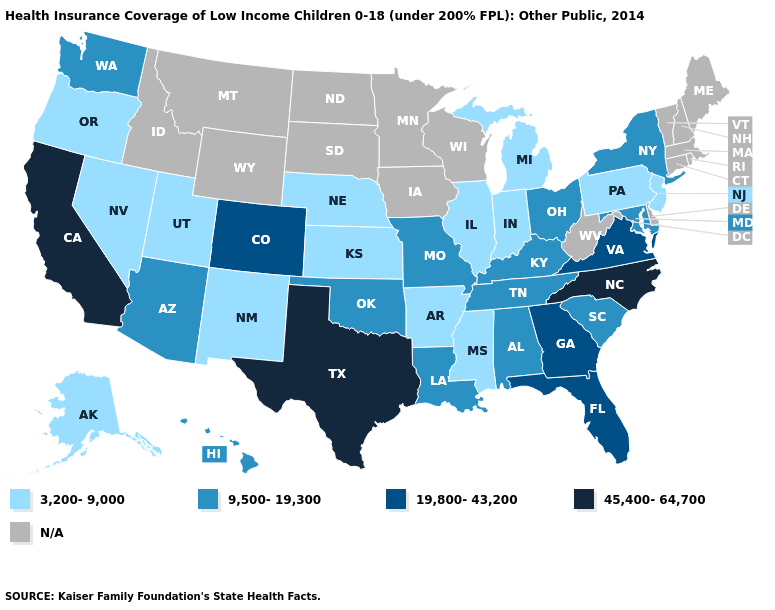How many symbols are there in the legend?
Keep it brief. 5. What is the lowest value in the Northeast?
Be succinct. 3,200-9,000. Among the states that border Oklahoma , does Arkansas have the lowest value?
Short answer required. Yes. Name the states that have a value in the range 3,200-9,000?
Keep it brief. Alaska, Arkansas, Illinois, Indiana, Kansas, Michigan, Mississippi, Nebraska, Nevada, New Jersey, New Mexico, Oregon, Pennsylvania, Utah. Name the states that have a value in the range N/A?
Write a very short answer. Connecticut, Delaware, Idaho, Iowa, Maine, Massachusetts, Minnesota, Montana, New Hampshire, North Dakota, Rhode Island, South Dakota, Vermont, West Virginia, Wisconsin, Wyoming. Which states hav the highest value in the Northeast?
Give a very brief answer. New York. What is the value of North Dakota?
Keep it brief. N/A. Does the map have missing data?
Concise answer only. Yes. How many symbols are there in the legend?
Write a very short answer. 5. What is the value of Alaska?
Be succinct. 3,200-9,000. Among the states that border Texas , which have the lowest value?
Concise answer only. Arkansas, New Mexico. Is the legend a continuous bar?
Keep it brief. No. Name the states that have a value in the range 45,400-64,700?
Keep it brief. California, North Carolina, Texas. Name the states that have a value in the range 3,200-9,000?
Write a very short answer. Alaska, Arkansas, Illinois, Indiana, Kansas, Michigan, Mississippi, Nebraska, Nevada, New Jersey, New Mexico, Oregon, Pennsylvania, Utah. What is the lowest value in states that border New Mexico?
Write a very short answer. 3,200-9,000. 